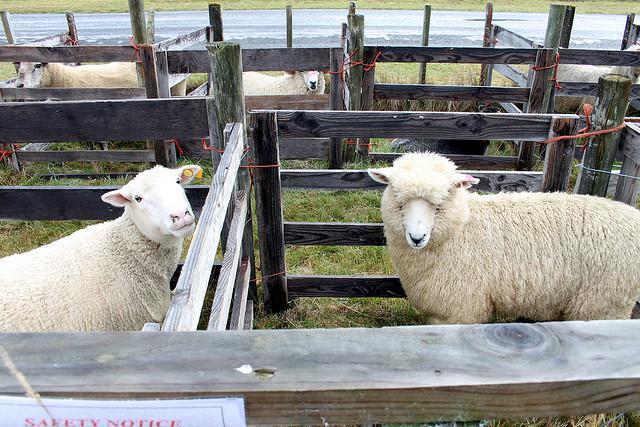How many sheep are there?
Give a very brief answer. 4. How many sheep are in the photo?
Give a very brief answer. 3. 